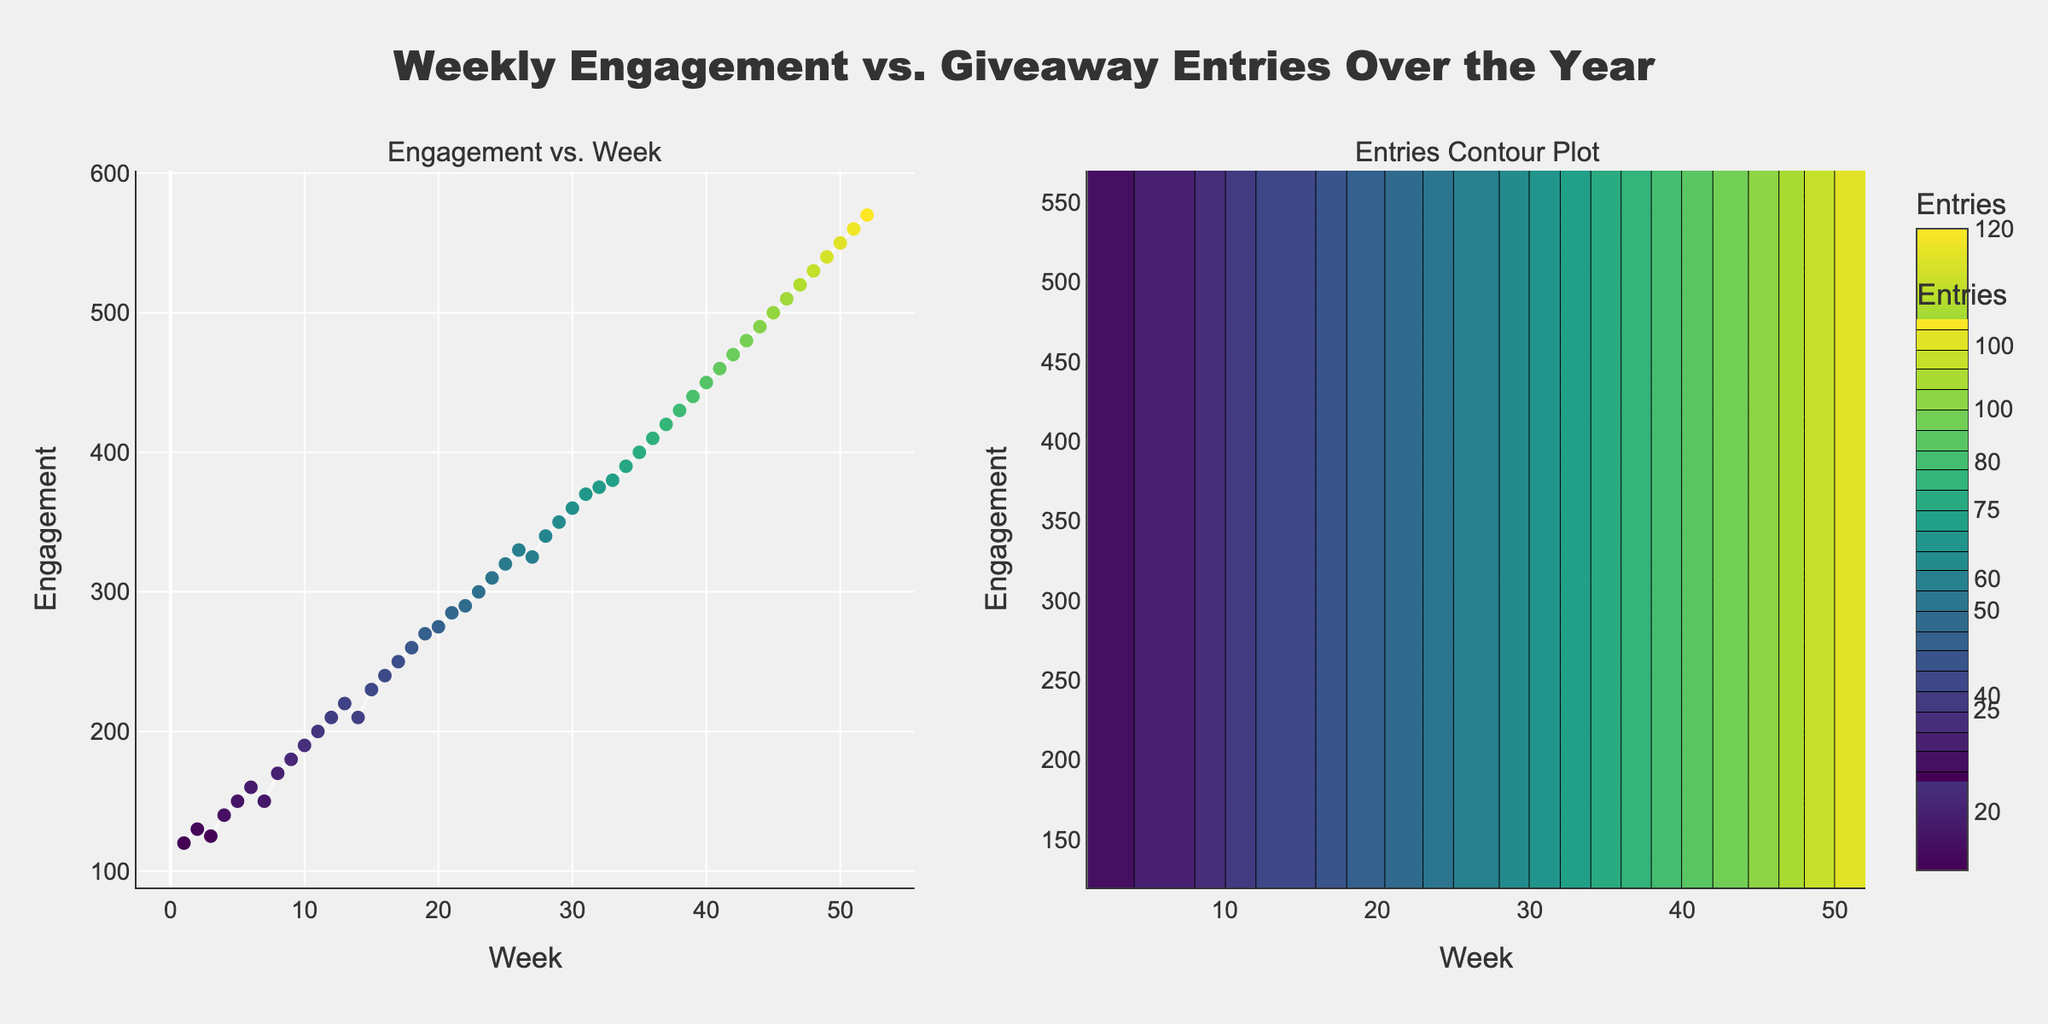What does the title of the figure say? The title of the figure is displayed at the top, centered and uses a larger, bold font to make it stand out. It reads "Weekly Engagement vs. Giveaway Entries Over the Year".
Answer: "Weekly Engagement vs. Giveaway Entries Over the Year" What are the x-axis labels for the contour plot? The x-axis label for the contour plot is displayed at the bottom of the contour subplot. It reads "Week".
Answer: "Week" How many data points are there in the scatter plot? By counting the markers on the scatter plot, we see that there is one for each week in the year. Since there are 52 weeks, there are 52 data points.
Answer: 52 During which week did the weekly engagement reach 400? The scatter plot in the first subplot shows weekly engagement values plotted against weeks. By looking where the dotted line intersects 400 on the y-axis, it is during week 35.
Answer: Week 35 What is the range of entries values in the contour plot? The colorbar on the right side of the contour plot shows the range of entries values. It ranges from 10 to 120.
Answer: 10 to 120 When the entries are at 52, what is the approximate engagement level? Checking the color scale and crossing reference with the bold scatter dots, entries of 52 correspond to an engagement of approximately 310 (in Week 24).
Answer: 310 Compare the engagement levels between Week 10 and Week 50. Which one is higher? By checking the scatter plot, Week 10 has approximately 190 engagement, and Week 50 has approximately 550 engagement. Week 50 is higher.
Answer: Week 50 Identify the week with the steepest increase in engagement. By observing the scatter plot, the steepest incline can be spotted. The largest difference appears between Week 45 and Week 46. The engagement jumps from 490 to 510, an increase of 20.
Answer: Week 45 to Week 46 What is the correlation pattern between engagement and entries? The general trend in the scatter plot and the contour plot shows that as weeks progress, both engagement and entries increase, suggesting a positive correlation.
Answer: Positive correlation 